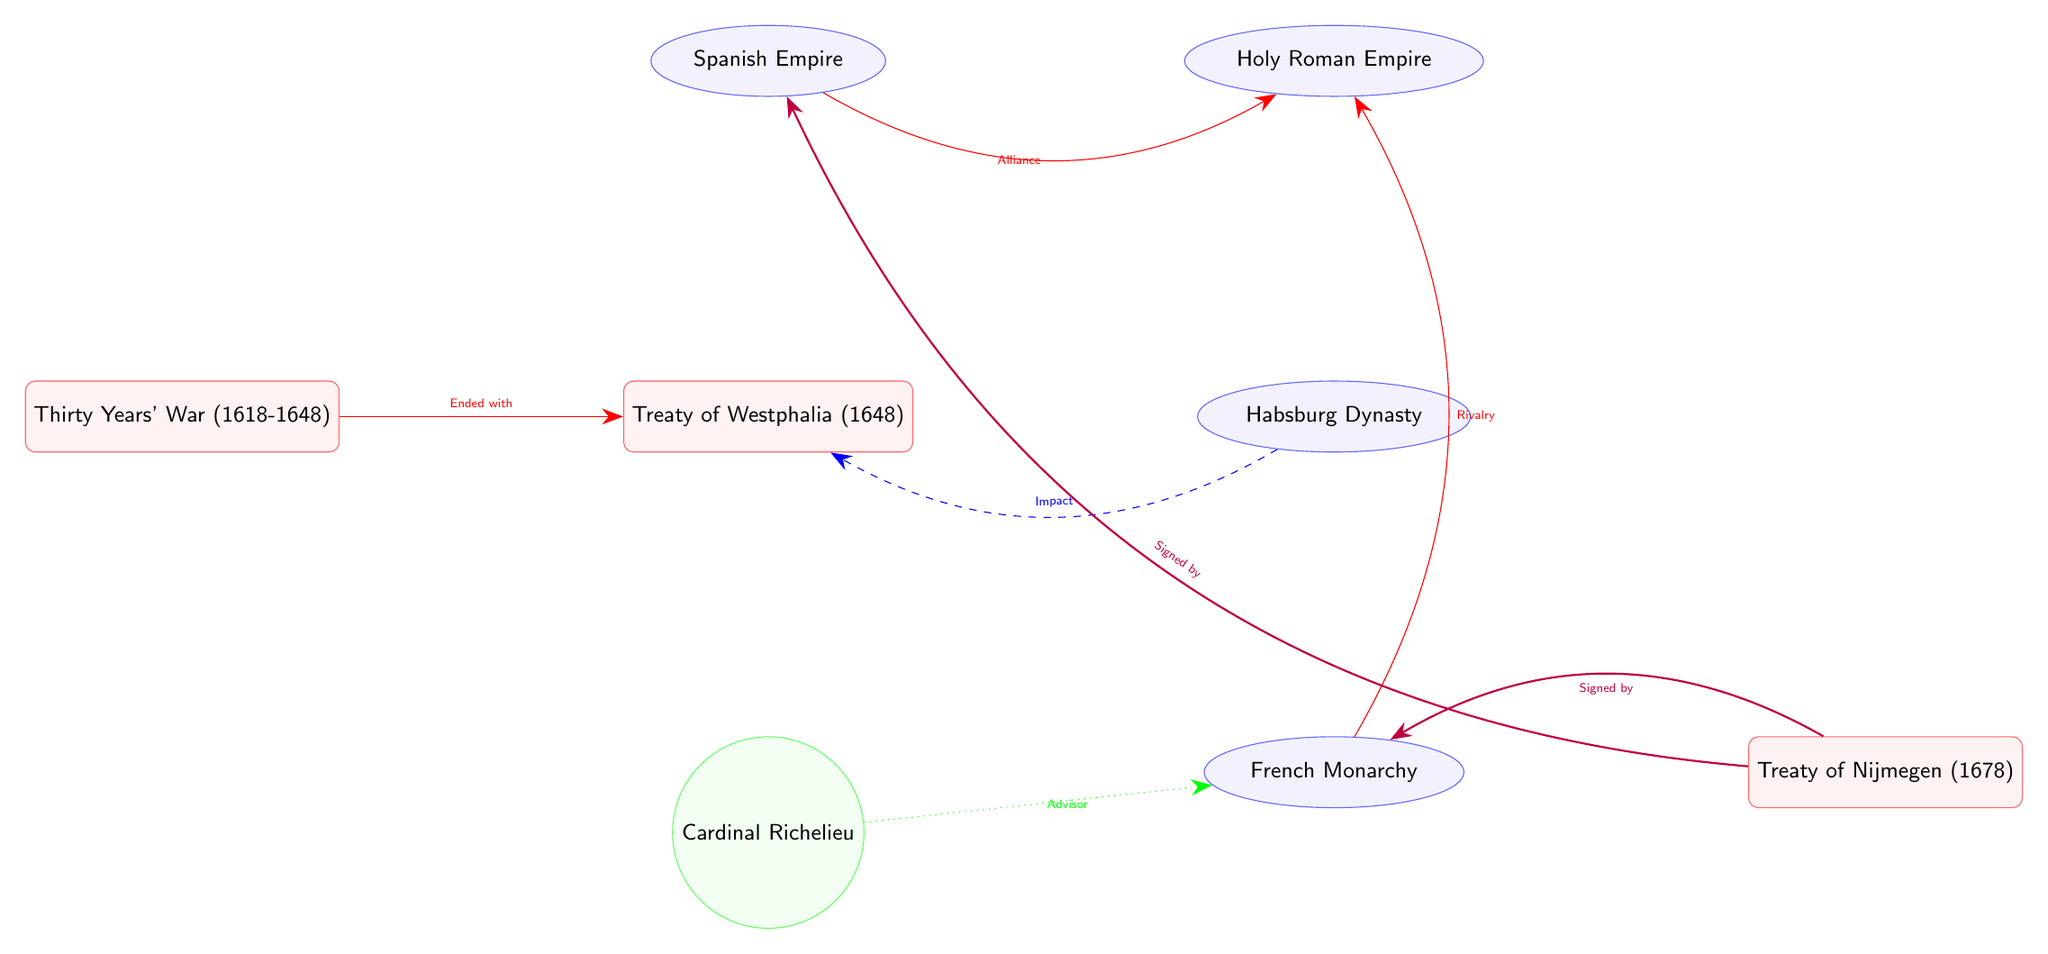What event ended with the Treaty of Westphalia? The diagram shows the "Thirty Years' War (1618-1648)" connected to the "Treaty of Westphalia (1648)" with a relationship arrow labeled "Ended with." This indicates that the Thirty Years' War was the event that led to the signing of the Treaty of Westphalia.
Answer: Thirty Years' War (1618-1648) Who is connected as an advisor to the French Monarchy? The diagram shows an arrow labeled "Advisor" pointing from "Cardinal Richelieu" to "French Monarchy." This indicates that Cardinal Richelieu is recognized as an advisor to this entity in the context of the political alliances depicted.
Answer: Cardinal Richelieu What treaty is signed by both the French Monarchy and the Spanish Empire? The diagram illustrates that the "Treaty of Nijmegen (1678)" is connected with arrows labeled "Signed by" from both "French Monarchy" and "Spanish Empire." Thus, this treaty involved both powers in its signing.
Answer: Treaty of Nijmegen (1678) How many major entities (nations or dynasties) are depicted in the diagram? The diagram includes four major entities: "Habsburg Dynasty," "Spanish Empire," "French Monarchy," and "Holy Roman Empire." Counting these entities gives a total number.
Answer: 4 What is the relationship between the Spanish Empire and the Holy Roman Empire? According to the diagram, there is an arrow labeled "Alliance" from "Spanish Empire" to "Holy Roman Empire," indicating a formal alliance between these two entities.
Answer: Alliance What influence does the Habsburg Dynasty have on the Treaty of Westphalia? The diagram illustrates an influence connection from "Habsburg Dynasty" to "Treaty of Westphalia," indicating that the Habsburg Dynasty had an impact on this treaty, especially in the context of European politics at the time.
Answer: Impact What is the role of Cardinal Richelieu in the diagram? The diagram shows an arrow labeled "Advisor" from "Cardinal Richelieu" to "French Monarchy," suggesting that his role is primarily as an advisor to the French Monarchy within the political landscape depicted.
Answer: Advisor What is the relationship between the French Monarchy and the Holy Roman Empire? The diagram depicts a relationship arrow labeled "Rivalry" pointing from "French Monarchy" to "Holy Roman Empire," indicating a competitive or hostile relationship between these two powers.
Answer: Rivalry 